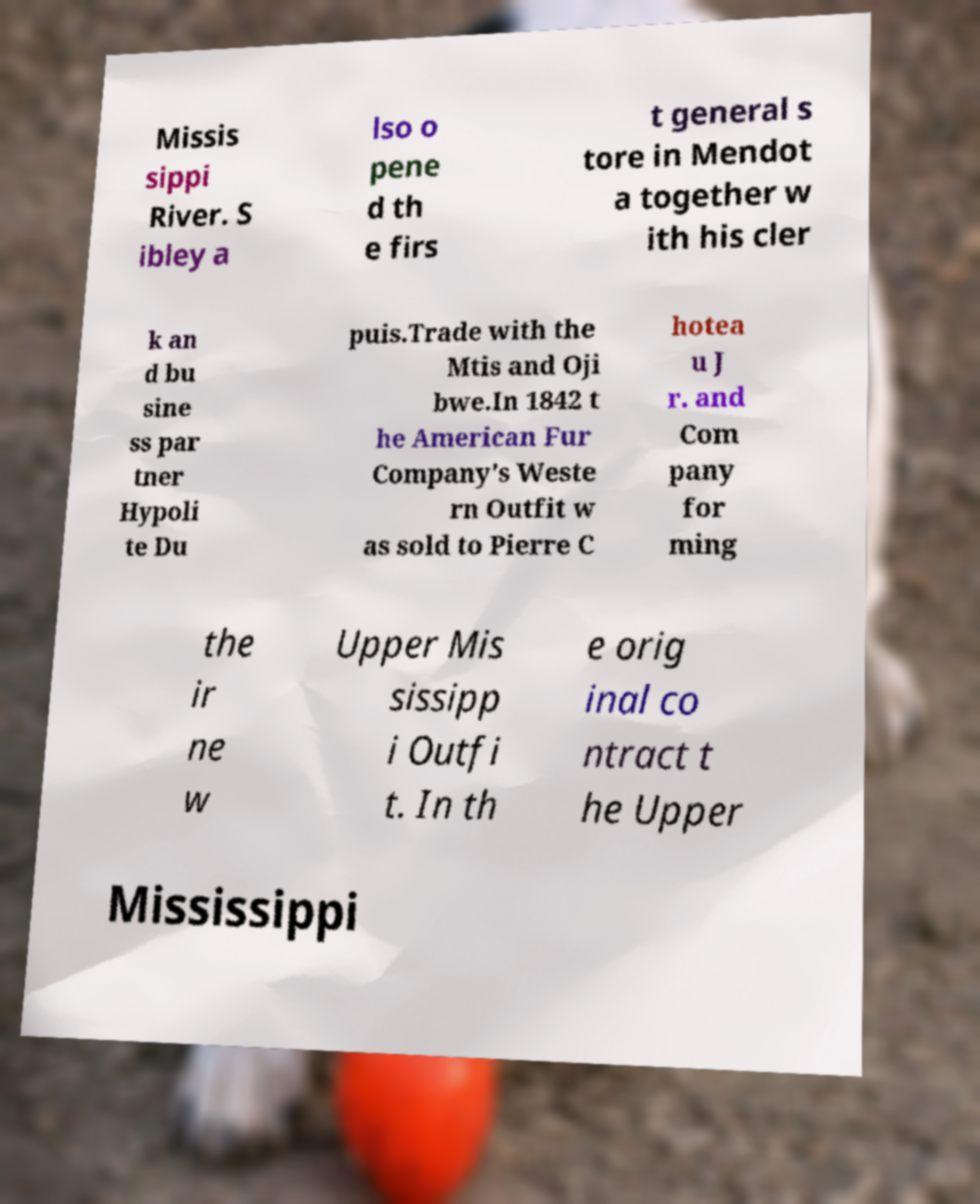Please read and relay the text visible in this image. What does it say? Missis sippi River. S ibley a lso o pene d th e firs t general s tore in Mendot a together w ith his cler k an d bu sine ss par tner Hypoli te Du puis.Trade with the Mtis and Oji bwe.In 1842 t he American Fur Company's Weste rn Outfit w as sold to Pierre C hotea u J r. and Com pany for ming the ir ne w Upper Mis sissipp i Outfi t. In th e orig inal co ntract t he Upper Mississippi 